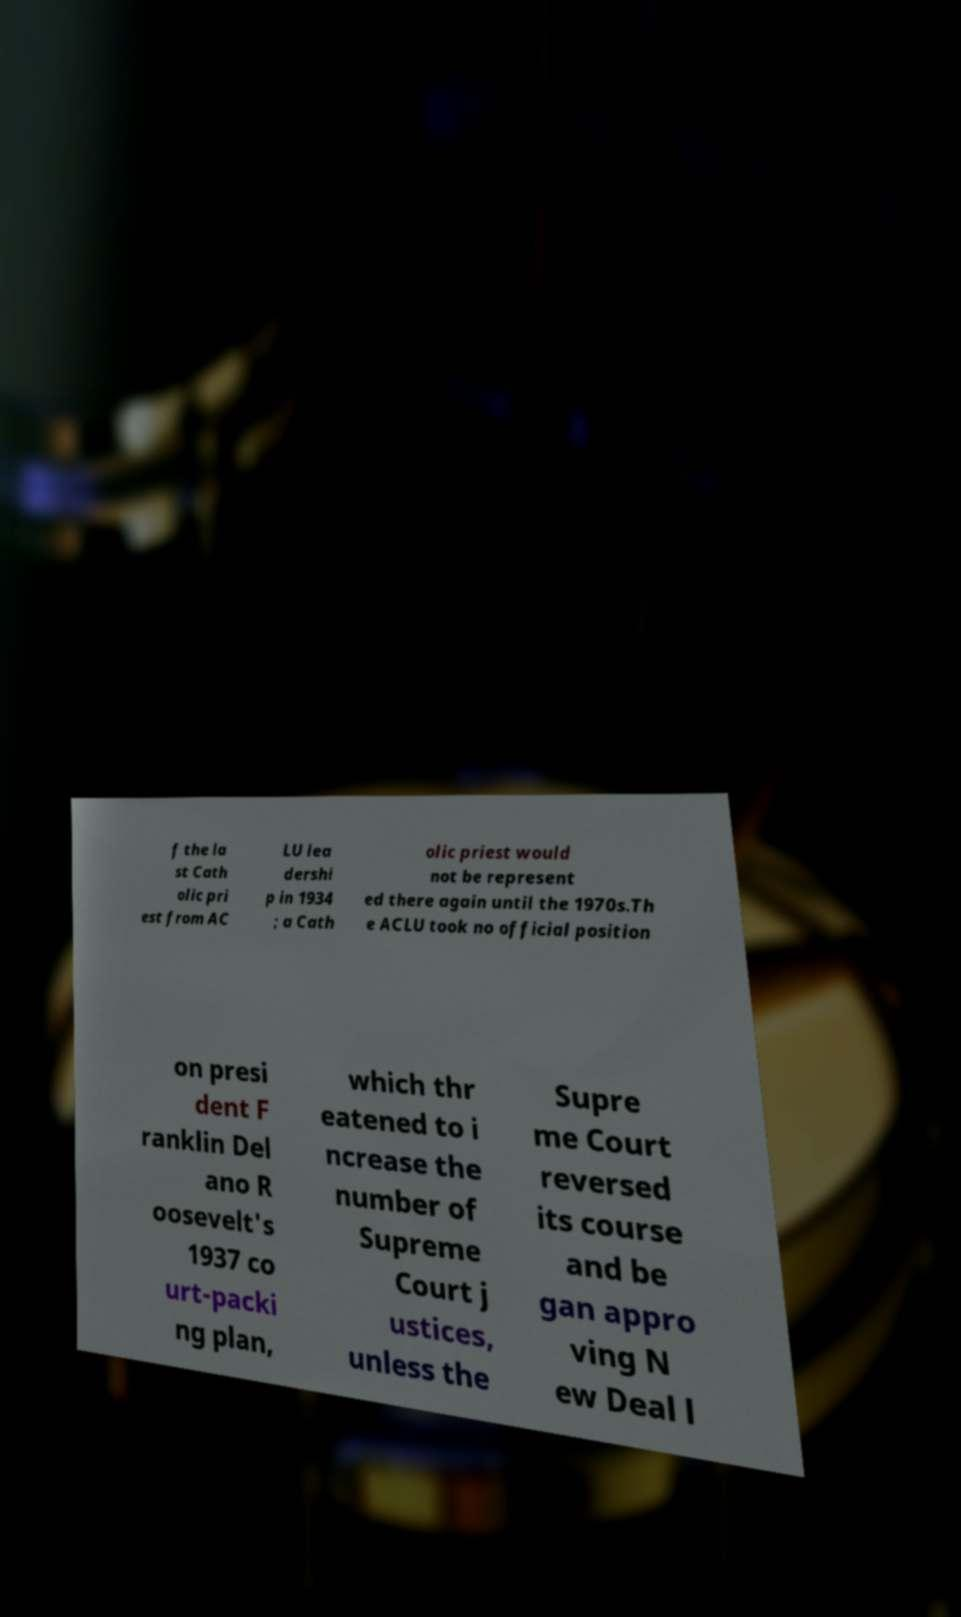What messages or text are displayed in this image? I need them in a readable, typed format. f the la st Cath olic pri est from AC LU lea dershi p in 1934 ; a Cath olic priest would not be represent ed there again until the 1970s.Th e ACLU took no official position on presi dent F ranklin Del ano R oosevelt's 1937 co urt-packi ng plan, which thr eatened to i ncrease the number of Supreme Court j ustices, unless the Supre me Court reversed its course and be gan appro ving N ew Deal l 